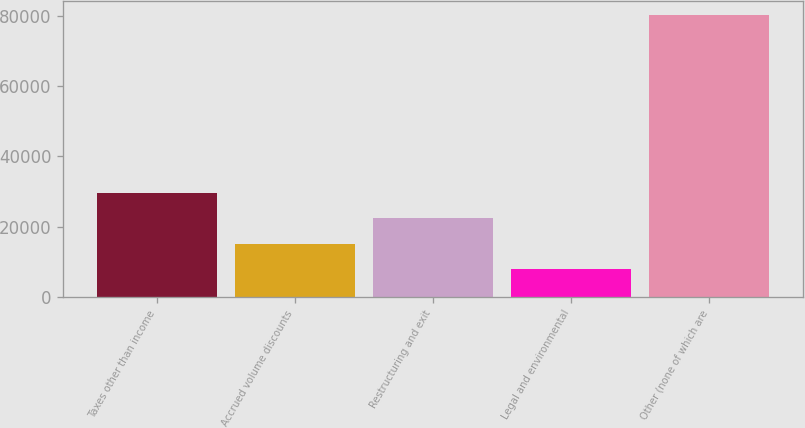Convert chart. <chart><loc_0><loc_0><loc_500><loc_500><bar_chart><fcel>Taxes other than income<fcel>Accrued volume discounts<fcel>Restructuring and exit<fcel>Legal and environmental<fcel>Other (none of which are<nl><fcel>29533.1<fcel>15089.7<fcel>22311.4<fcel>7868<fcel>80085<nl></chart> 